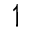Convert formula to latex. <formula><loc_0><loc_0><loc_500><loc_500>\upharpoonleft</formula> 